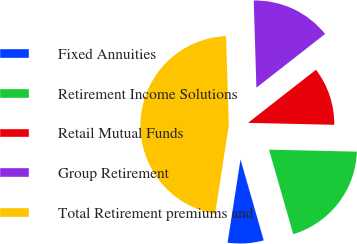Convert chart to OTSL. <chart><loc_0><loc_0><loc_500><loc_500><pie_chart><fcel>Fixed Annuities<fcel>Retirement Income Solutions<fcel>Retail Mutual Funds<fcel>Group Retirement<fcel>Total Retirement premiums and<nl><fcel>6.9%<fcel>20.19%<fcel>10.92%<fcel>14.93%<fcel>47.06%<nl></chart> 